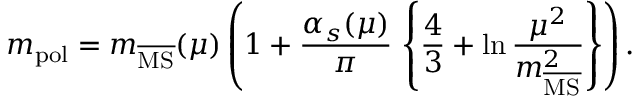<formula> <loc_0><loc_0><loc_500><loc_500>m _ { p o l } = m _ { \overline { M S } } ( \mu ) \left ( 1 + \frac { \alpha _ { s } ( \mu ) } { \pi } \, \left \{ \frac { 4 } { 3 } + \ln \frac { \mu ^ { 2 } } { m _ { \overline { M S } } ^ { 2 } } \right \} \right ) .</formula> 